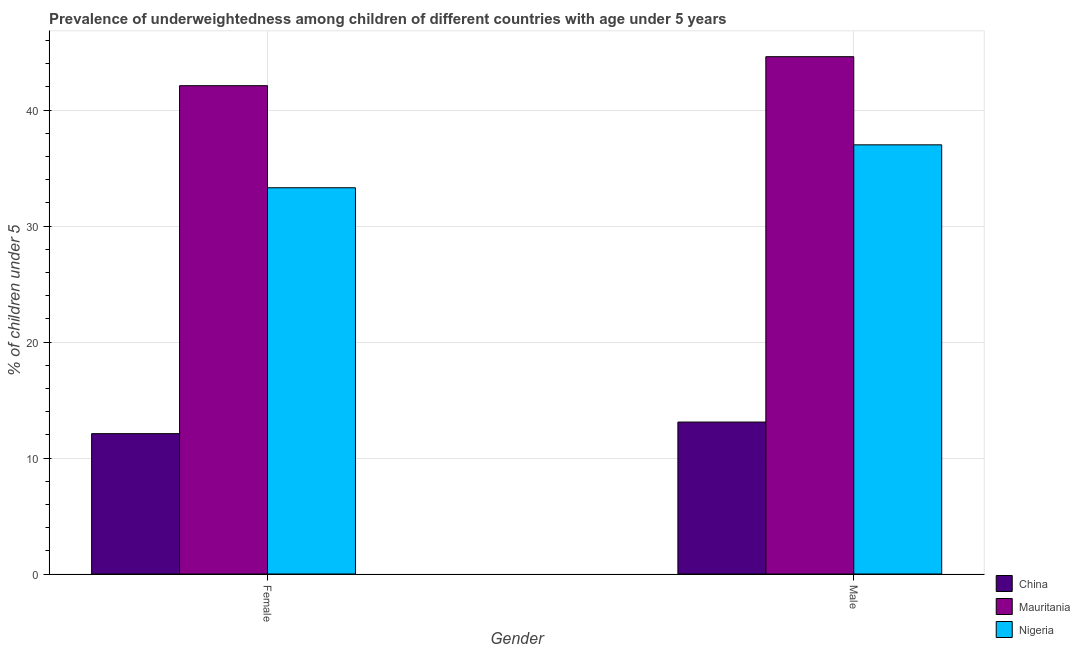How many bars are there on the 1st tick from the right?
Provide a succinct answer. 3. What is the label of the 1st group of bars from the left?
Your answer should be very brief. Female. What is the percentage of underweighted female children in Mauritania?
Keep it short and to the point. 42.1. Across all countries, what is the maximum percentage of underweighted male children?
Your response must be concise. 44.6. Across all countries, what is the minimum percentage of underweighted female children?
Provide a short and direct response. 12.1. In which country was the percentage of underweighted female children maximum?
Your answer should be very brief. Mauritania. What is the total percentage of underweighted female children in the graph?
Provide a succinct answer. 87.5. What is the difference between the percentage of underweighted male children in Mauritania and that in China?
Give a very brief answer. 31.5. What is the difference between the percentage of underweighted male children in Mauritania and the percentage of underweighted female children in China?
Your answer should be very brief. 32.5. What is the average percentage of underweighted male children per country?
Make the answer very short. 31.57. What is the difference between the percentage of underweighted female children and percentage of underweighted male children in China?
Offer a very short reply. -1. What is the ratio of the percentage of underweighted female children in Mauritania to that in China?
Your response must be concise. 3.48. Is the percentage of underweighted male children in China less than that in Nigeria?
Your answer should be compact. Yes. In how many countries, is the percentage of underweighted female children greater than the average percentage of underweighted female children taken over all countries?
Make the answer very short. 2. What does the 3rd bar from the left in Male represents?
Provide a short and direct response. Nigeria. What does the 1st bar from the right in Male represents?
Give a very brief answer. Nigeria. How many bars are there?
Give a very brief answer. 6. Are all the bars in the graph horizontal?
Provide a succinct answer. No. Does the graph contain any zero values?
Offer a terse response. No. Does the graph contain grids?
Offer a terse response. Yes. How many legend labels are there?
Offer a terse response. 3. What is the title of the graph?
Give a very brief answer. Prevalence of underweightedness among children of different countries with age under 5 years. What is the label or title of the X-axis?
Offer a terse response. Gender. What is the label or title of the Y-axis?
Keep it short and to the point.  % of children under 5. What is the  % of children under 5 in China in Female?
Offer a terse response. 12.1. What is the  % of children under 5 in Mauritania in Female?
Give a very brief answer. 42.1. What is the  % of children under 5 of Nigeria in Female?
Give a very brief answer. 33.3. What is the  % of children under 5 in China in Male?
Your answer should be very brief. 13.1. What is the  % of children under 5 in Mauritania in Male?
Provide a short and direct response. 44.6. What is the  % of children under 5 in Nigeria in Male?
Offer a terse response. 37. Across all Gender, what is the maximum  % of children under 5 of China?
Offer a terse response. 13.1. Across all Gender, what is the maximum  % of children under 5 of Mauritania?
Provide a succinct answer. 44.6. Across all Gender, what is the maximum  % of children under 5 in Nigeria?
Ensure brevity in your answer.  37. Across all Gender, what is the minimum  % of children under 5 in China?
Your answer should be very brief. 12.1. Across all Gender, what is the minimum  % of children under 5 of Mauritania?
Give a very brief answer. 42.1. Across all Gender, what is the minimum  % of children under 5 in Nigeria?
Make the answer very short. 33.3. What is the total  % of children under 5 in China in the graph?
Offer a very short reply. 25.2. What is the total  % of children under 5 in Mauritania in the graph?
Your response must be concise. 86.7. What is the total  % of children under 5 in Nigeria in the graph?
Make the answer very short. 70.3. What is the difference between the  % of children under 5 in China in Female and that in Male?
Offer a very short reply. -1. What is the difference between the  % of children under 5 in Nigeria in Female and that in Male?
Your answer should be compact. -3.7. What is the difference between the  % of children under 5 in China in Female and the  % of children under 5 in Mauritania in Male?
Make the answer very short. -32.5. What is the difference between the  % of children under 5 in China in Female and the  % of children under 5 in Nigeria in Male?
Offer a terse response. -24.9. What is the average  % of children under 5 of Mauritania per Gender?
Provide a succinct answer. 43.35. What is the average  % of children under 5 in Nigeria per Gender?
Make the answer very short. 35.15. What is the difference between the  % of children under 5 of China and  % of children under 5 of Mauritania in Female?
Give a very brief answer. -30. What is the difference between the  % of children under 5 in China and  % of children under 5 in Nigeria in Female?
Make the answer very short. -21.2. What is the difference between the  % of children under 5 in China and  % of children under 5 in Mauritania in Male?
Provide a succinct answer. -31.5. What is the difference between the  % of children under 5 in China and  % of children under 5 in Nigeria in Male?
Your answer should be compact. -23.9. What is the ratio of the  % of children under 5 in China in Female to that in Male?
Your response must be concise. 0.92. What is the ratio of the  % of children under 5 of Mauritania in Female to that in Male?
Your response must be concise. 0.94. What is the difference between the highest and the second highest  % of children under 5 of Mauritania?
Your answer should be compact. 2.5. What is the difference between the highest and the lowest  % of children under 5 in China?
Provide a short and direct response. 1. What is the difference between the highest and the lowest  % of children under 5 of Mauritania?
Give a very brief answer. 2.5. What is the difference between the highest and the lowest  % of children under 5 in Nigeria?
Offer a very short reply. 3.7. 